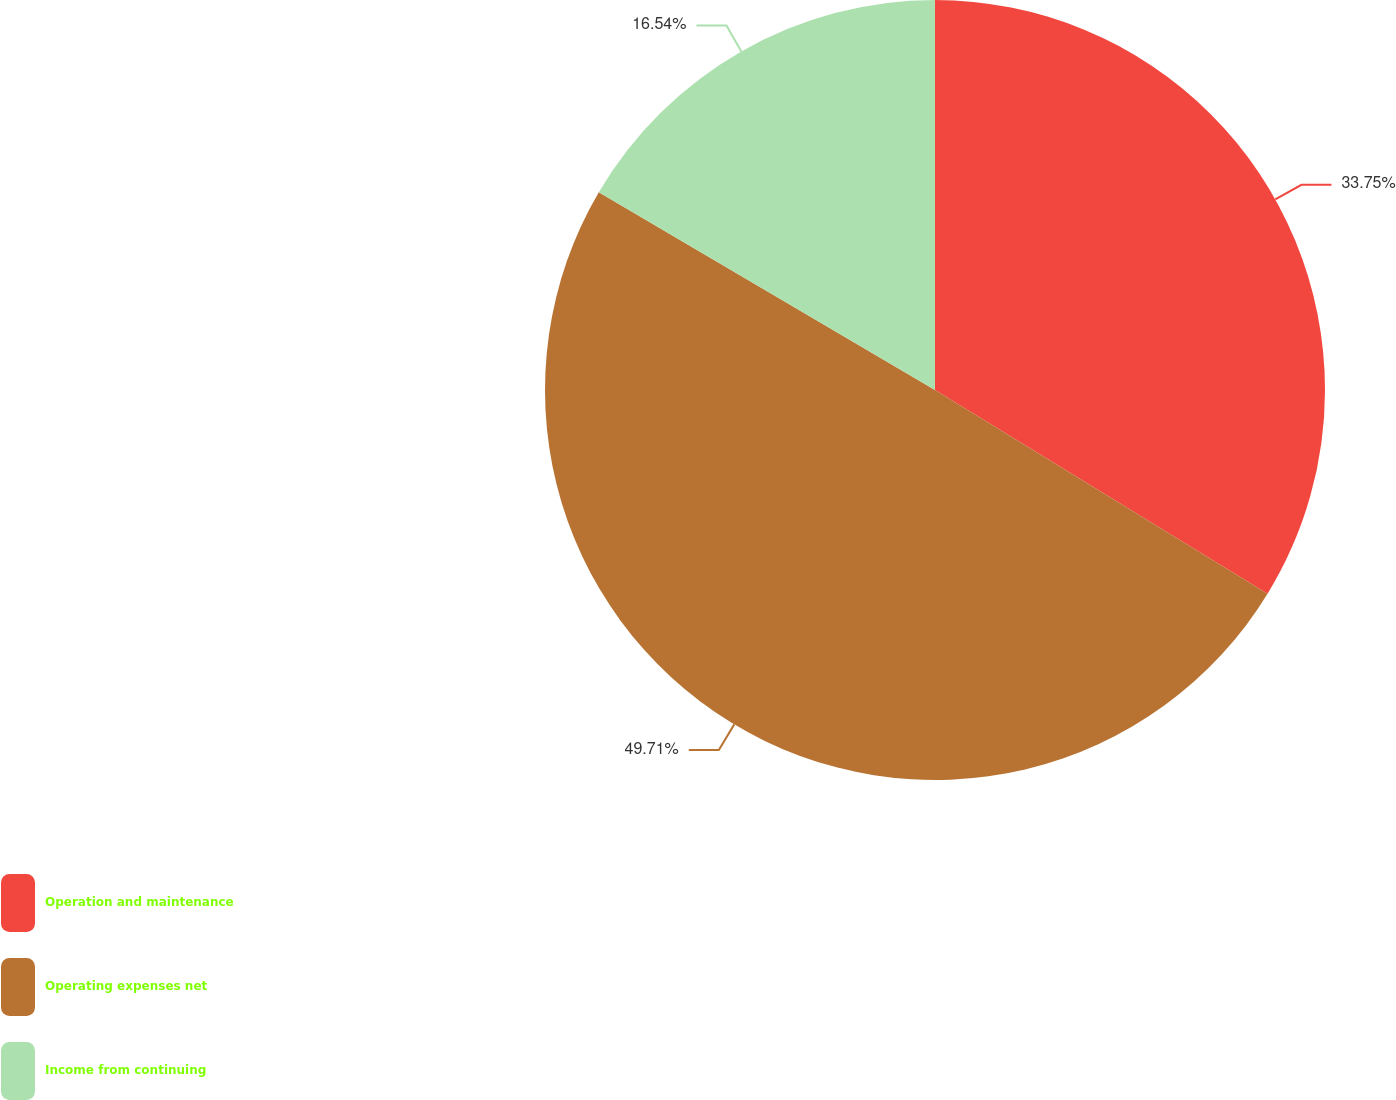<chart> <loc_0><loc_0><loc_500><loc_500><pie_chart><fcel>Operation and maintenance<fcel>Operating expenses net<fcel>Income from continuing<nl><fcel>33.75%<fcel>49.71%<fcel>16.54%<nl></chart> 